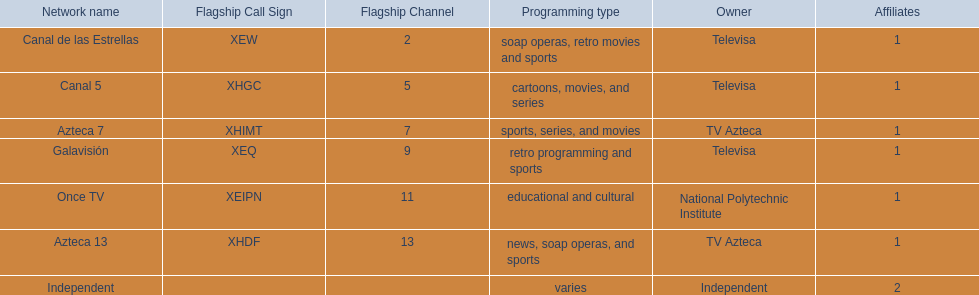What are each of the networks? Canal de las Estrellas, Canal 5, Azteca 7, Galavisión, Once TV, Azteca 13, Independent. Who owns them? Televisa, Televisa, TV Azteca, Televisa, National Polytechnic Institute, TV Azteca, Independent. Which networks aren't owned by televisa? Azteca 7, Once TV, Azteca 13, Independent. What type of programming do those networks offer? Sports, series, and movies, educational and cultural, news, soap operas, and sports, varies. And which network is the only one with sports? Azteca 7. 